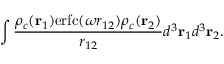<formula> <loc_0><loc_0><loc_500><loc_500>\int \frac { \rho _ { c } ( r _ { 1 } ) e r f c ( \omega r _ { 1 2 } ) \rho _ { c } ( r _ { 2 } ) } { r _ { 1 2 } } d ^ { 3 } r _ { 1 } d ^ { 3 } r _ { 2 } .</formula> 